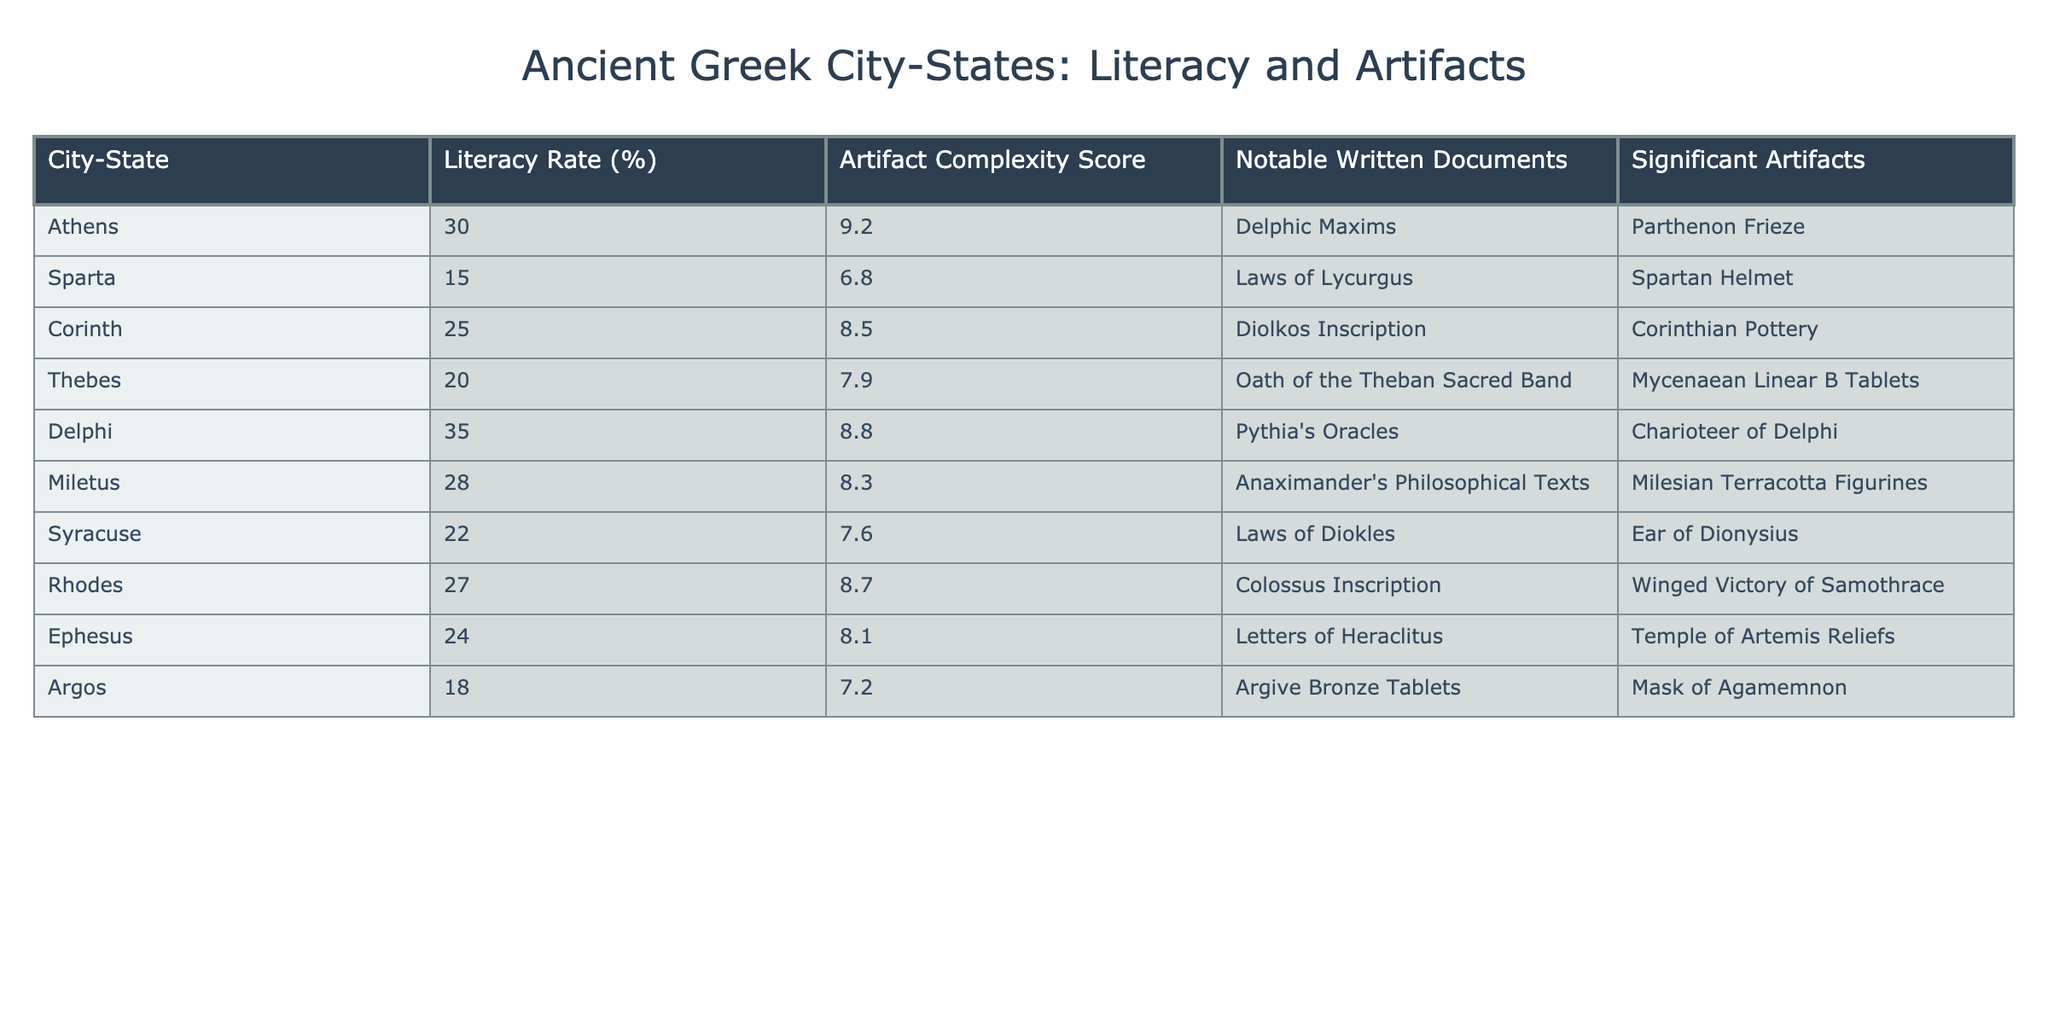What is the highest literacy rate among the city-states? The table shows the literacy rates for all the city-states. By examining the values, Athens has the highest literacy rate at 30%.
Answer: 30% What is the artifact complexity score of Sparta? Looking at the row for Sparta in the table, the artifact complexity score is listed as 6.8.
Answer: 6.8 What are the notable written documents from Delphi? The table specifies that the notable written documents associated with Delphi are the Pythia's Oracles.
Answer: Pythia's Oracles Which city-state has the lowest artifact complexity score? By reviewing the artifact complexity scores listed, Sparta has the lowest score at 6.8.
Answer: Sparta What is the average literacy rate of the city-states listed? To find the average, sum all literacy rates (30 + 15 + 25 + 20 + 35 + 28 + 22 + 27 + 24 + 18 =  224), and divide by the number of city-states (10). So, 224 / 10 = 22.4.
Answer: 22.4 Does Athens have a complexity score higher than 8? By checking Athens's artifact complexity score of 9.2, which is greater than 8, the answer is yes.
Answer: Yes Is there a correlation where higher literacy rates correspond to higher artifact complexity scores? Assessing the pairs in the table, as we see that city-states with higher literacy rates (like Delphi and Athens) also possess higher artifact complexity scores. Hence, there seems to be a positive correlation.
Answer: Yes What is the difference in artifact complexity scores between Athens and Syracuse? The complexity score for Athens is 9.2 and for Syracuse is 7.6. The difference is calculated as 9.2 - 7.6 = 1.6.
Answer: 1.6 Which city-state has a higher literacy rate, Argos or Miletus? Argos has a literacy rate of 18%, while Miletus has a literacy rate of 28%. Comparing these values shows that Miletus has the higher literacy rate.
Answer: Miletus In how many city-states is the artifact complexity score greater than 8? Reviewing the scores, the city-states with scores greater than 8 are Athens, Corinth, Delphi, Rhodes, and Miletus. Counting them gives us a total of 5 city-states.
Answer: 5 